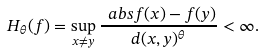<formula> <loc_0><loc_0><loc_500><loc_500>H _ { \theta } ( f ) = \sup _ { x \neq y } \frac { \ a b s { f ( x ) - f ( y ) } } { d ( x , y ) ^ { \theta } } < \infty .</formula> 